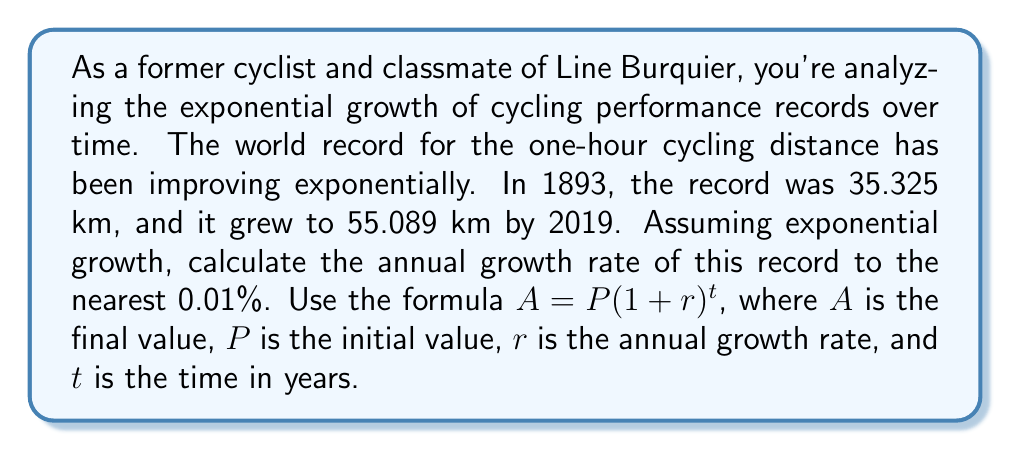Show me your answer to this math problem. Let's approach this step-by-step using the exponential growth formula:

1) We have:
   $P = 35.325$ km (1893 record)
   $A = 55.089$ km (2019 record)
   $t = 2019 - 1893 = 126$ years

2) We need to solve for $r$ in the equation:
   $55.089 = 35.325(1 + r)^{126}$

3) Divide both sides by 35.325:
   $\frac{55.089}{35.325} = (1 + r)^{126}$

4) Take the 126th root of both sides:
   $(\frac{55.089}{35.325})^{\frac{1}{126}} = 1 + r$

5) Subtract 1 from both sides:
   $(\frac{55.089}{35.325})^{\frac{1}{126}} - 1 = r$

6) Calculate:
   $r = (1.5594)^{\frac{1}{126}} - 1$
   $r = 1.003533 - 1$
   $r = 0.003533$

7) Convert to a percentage:
   $r = 0.3533\%$

8) Round to the nearest 0.01%:
   $r \approx 0.35\%$
Answer: The annual growth rate of the one-hour cycling distance world record from 1893 to 2019 was approximately 0.35%. 